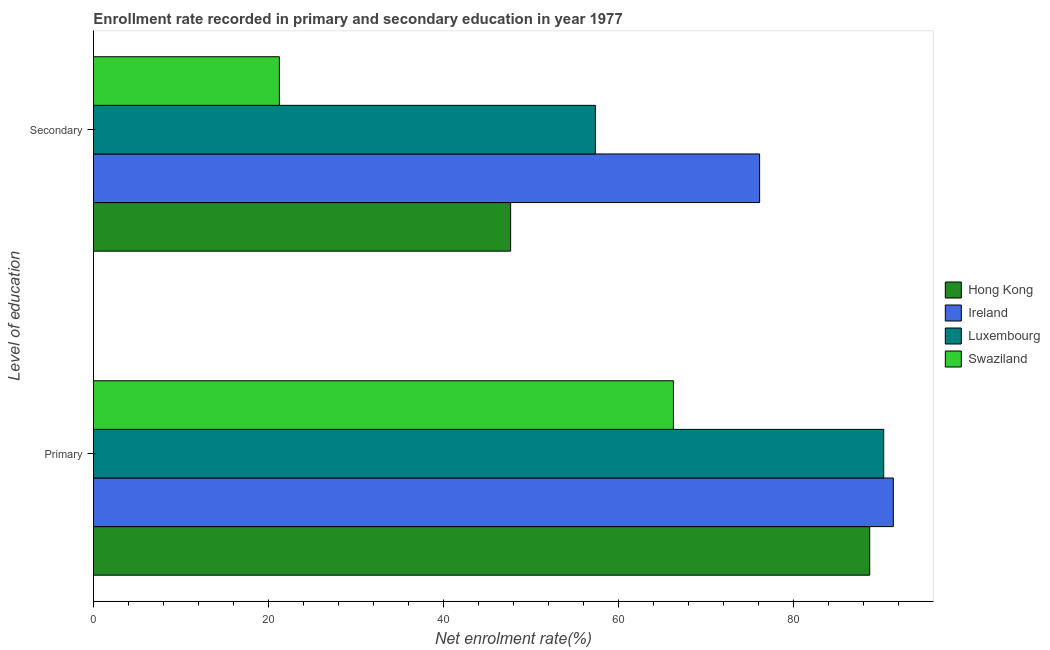How many different coloured bars are there?
Offer a terse response. 4. Are the number of bars on each tick of the Y-axis equal?
Keep it short and to the point. Yes. How many bars are there on the 1st tick from the top?
Make the answer very short. 4. What is the label of the 2nd group of bars from the top?
Make the answer very short. Primary. What is the enrollment rate in primary education in Hong Kong?
Give a very brief answer. 88.7. Across all countries, what is the maximum enrollment rate in primary education?
Your answer should be very brief. 91.4. Across all countries, what is the minimum enrollment rate in primary education?
Your answer should be compact. 66.27. In which country was the enrollment rate in primary education maximum?
Your answer should be very brief. Ireland. In which country was the enrollment rate in secondary education minimum?
Your answer should be very brief. Swaziland. What is the total enrollment rate in primary education in the graph?
Offer a terse response. 336.67. What is the difference between the enrollment rate in secondary education in Ireland and that in Hong Kong?
Offer a very short reply. 28.45. What is the difference between the enrollment rate in secondary education in Hong Kong and the enrollment rate in primary education in Luxembourg?
Keep it short and to the point. -42.63. What is the average enrollment rate in secondary education per country?
Offer a terse response. 50.6. What is the difference between the enrollment rate in secondary education and enrollment rate in primary education in Luxembourg?
Make the answer very short. -32.95. In how many countries, is the enrollment rate in secondary education greater than 88 %?
Your response must be concise. 0. What is the ratio of the enrollment rate in primary education in Hong Kong to that in Luxembourg?
Make the answer very short. 0.98. Is the enrollment rate in primary education in Luxembourg less than that in Swaziland?
Offer a terse response. No. What does the 4th bar from the top in Secondary represents?
Give a very brief answer. Hong Kong. What does the 1st bar from the bottom in Secondary represents?
Ensure brevity in your answer.  Hong Kong. How many bars are there?
Your answer should be compact. 8. Are all the bars in the graph horizontal?
Make the answer very short. Yes. How many countries are there in the graph?
Provide a succinct answer. 4. Are the values on the major ticks of X-axis written in scientific E-notation?
Provide a short and direct response. No. Does the graph contain any zero values?
Provide a succinct answer. No. How are the legend labels stacked?
Your answer should be very brief. Vertical. What is the title of the graph?
Your response must be concise. Enrollment rate recorded in primary and secondary education in year 1977. What is the label or title of the X-axis?
Ensure brevity in your answer.  Net enrolment rate(%). What is the label or title of the Y-axis?
Provide a short and direct response. Level of education. What is the Net enrolment rate(%) of Hong Kong in Primary?
Keep it short and to the point. 88.7. What is the Net enrolment rate(%) in Ireland in Primary?
Provide a succinct answer. 91.4. What is the Net enrolment rate(%) of Luxembourg in Primary?
Keep it short and to the point. 90.3. What is the Net enrolment rate(%) of Swaziland in Primary?
Provide a short and direct response. 66.27. What is the Net enrolment rate(%) of Hong Kong in Secondary?
Make the answer very short. 47.67. What is the Net enrolment rate(%) in Ireland in Secondary?
Offer a very short reply. 76.12. What is the Net enrolment rate(%) of Luxembourg in Secondary?
Ensure brevity in your answer.  57.35. What is the Net enrolment rate(%) of Swaziland in Secondary?
Your answer should be very brief. 21.25. Across all Level of education, what is the maximum Net enrolment rate(%) in Hong Kong?
Your response must be concise. 88.7. Across all Level of education, what is the maximum Net enrolment rate(%) in Ireland?
Keep it short and to the point. 91.4. Across all Level of education, what is the maximum Net enrolment rate(%) in Luxembourg?
Your answer should be very brief. 90.3. Across all Level of education, what is the maximum Net enrolment rate(%) of Swaziland?
Give a very brief answer. 66.27. Across all Level of education, what is the minimum Net enrolment rate(%) in Hong Kong?
Provide a succinct answer. 47.67. Across all Level of education, what is the minimum Net enrolment rate(%) of Ireland?
Give a very brief answer. 76.12. Across all Level of education, what is the minimum Net enrolment rate(%) of Luxembourg?
Provide a short and direct response. 57.35. Across all Level of education, what is the minimum Net enrolment rate(%) of Swaziland?
Your response must be concise. 21.25. What is the total Net enrolment rate(%) of Hong Kong in the graph?
Offer a terse response. 136.37. What is the total Net enrolment rate(%) in Ireland in the graph?
Offer a very short reply. 167.51. What is the total Net enrolment rate(%) of Luxembourg in the graph?
Your answer should be compact. 147.65. What is the total Net enrolment rate(%) in Swaziland in the graph?
Your answer should be compact. 87.52. What is the difference between the Net enrolment rate(%) in Hong Kong in Primary and that in Secondary?
Make the answer very short. 41.03. What is the difference between the Net enrolment rate(%) of Ireland in Primary and that in Secondary?
Ensure brevity in your answer.  15.28. What is the difference between the Net enrolment rate(%) of Luxembourg in Primary and that in Secondary?
Provide a succinct answer. 32.95. What is the difference between the Net enrolment rate(%) of Swaziland in Primary and that in Secondary?
Keep it short and to the point. 45.03. What is the difference between the Net enrolment rate(%) of Hong Kong in Primary and the Net enrolment rate(%) of Ireland in Secondary?
Your answer should be compact. 12.58. What is the difference between the Net enrolment rate(%) in Hong Kong in Primary and the Net enrolment rate(%) in Luxembourg in Secondary?
Give a very brief answer. 31.35. What is the difference between the Net enrolment rate(%) of Hong Kong in Primary and the Net enrolment rate(%) of Swaziland in Secondary?
Make the answer very short. 67.46. What is the difference between the Net enrolment rate(%) of Ireland in Primary and the Net enrolment rate(%) of Luxembourg in Secondary?
Make the answer very short. 34.04. What is the difference between the Net enrolment rate(%) of Ireland in Primary and the Net enrolment rate(%) of Swaziland in Secondary?
Make the answer very short. 70.15. What is the difference between the Net enrolment rate(%) in Luxembourg in Primary and the Net enrolment rate(%) in Swaziland in Secondary?
Your response must be concise. 69.06. What is the average Net enrolment rate(%) in Hong Kong per Level of education?
Your answer should be compact. 68.18. What is the average Net enrolment rate(%) in Ireland per Level of education?
Provide a short and direct response. 83.76. What is the average Net enrolment rate(%) in Luxembourg per Level of education?
Provide a short and direct response. 73.83. What is the average Net enrolment rate(%) of Swaziland per Level of education?
Ensure brevity in your answer.  43.76. What is the difference between the Net enrolment rate(%) of Hong Kong and Net enrolment rate(%) of Ireland in Primary?
Offer a terse response. -2.7. What is the difference between the Net enrolment rate(%) in Hong Kong and Net enrolment rate(%) in Luxembourg in Primary?
Offer a very short reply. -1.6. What is the difference between the Net enrolment rate(%) of Hong Kong and Net enrolment rate(%) of Swaziland in Primary?
Provide a short and direct response. 22.43. What is the difference between the Net enrolment rate(%) of Ireland and Net enrolment rate(%) of Luxembourg in Primary?
Your answer should be compact. 1.1. What is the difference between the Net enrolment rate(%) in Ireland and Net enrolment rate(%) in Swaziland in Primary?
Provide a short and direct response. 25.13. What is the difference between the Net enrolment rate(%) of Luxembourg and Net enrolment rate(%) of Swaziland in Primary?
Ensure brevity in your answer.  24.03. What is the difference between the Net enrolment rate(%) of Hong Kong and Net enrolment rate(%) of Ireland in Secondary?
Offer a very short reply. -28.45. What is the difference between the Net enrolment rate(%) in Hong Kong and Net enrolment rate(%) in Luxembourg in Secondary?
Ensure brevity in your answer.  -9.69. What is the difference between the Net enrolment rate(%) of Hong Kong and Net enrolment rate(%) of Swaziland in Secondary?
Keep it short and to the point. 26.42. What is the difference between the Net enrolment rate(%) in Ireland and Net enrolment rate(%) in Luxembourg in Secondary?
Make the answer very short. 18.76. What is the difference between the Net enrolment rate(%) in Ireland and Net enrolment rate(%) in Swaziland in Secondary?
Keep it short and to the point. 54.87. What is the difference between the Net enrolment rate(%) of Luxembourg and Net enrolment rate(%) of Swaziland in Secondary?
Ensure brevity in your answer.  36.11. What is the ratio of the Net enrolment rate(%) of Hong Kong in Primary to that in Secondary?
Your answer should be very brief. 1.86. What is the ratio of the Net enrolment rate(%) of Ireland in Primary to that in Secondary?
Ensure brevity in your answer.  1.2. What is the ratio of the Net enrolment rate(%) of Luxembourg in Primary to that in Secondary?
Make the answer very short. 1.57. What is the ratio of the Net enrolment rate(%) in Swaziland in Primary to that in Secondary?
Make the answer very short. 3.12. What is the difference between the highest and the second highest Net enrolment rate(%) of Hong Kong?
Ensure brevity in your answer.  41.03. What is the difference between the highest and the second highest Net enrolment rate(%) of Ireland?
Keep it short and to the point. 15.28. What is the difference between the highest and the second highest Net enrolment rate(%) of Luxembourg?
Your answer should be compact. 32.95. What is the difference between the highest and the second highest Net enrolment rate(%) in Swaziland?
Provide a succinct answer. 45.03. What is the difference between the highest and the lowest Net enrolment rate(%) of Hong Kong?
Give a very brief answer. 41.03. What is the difference between the highest and the lowest Net enrolment rate(%) of Ireland?
Your answer should be very brief. 15.28. What is the difference between the highest and the lowest Net enrolment rate(%) of Luxembourg?
Offer a very short reply. 32.95. What is the difference between the highest and the lowest Net enrolment rate(%) of Swaziland?
Ensure brevity in your answer.  45.03. 